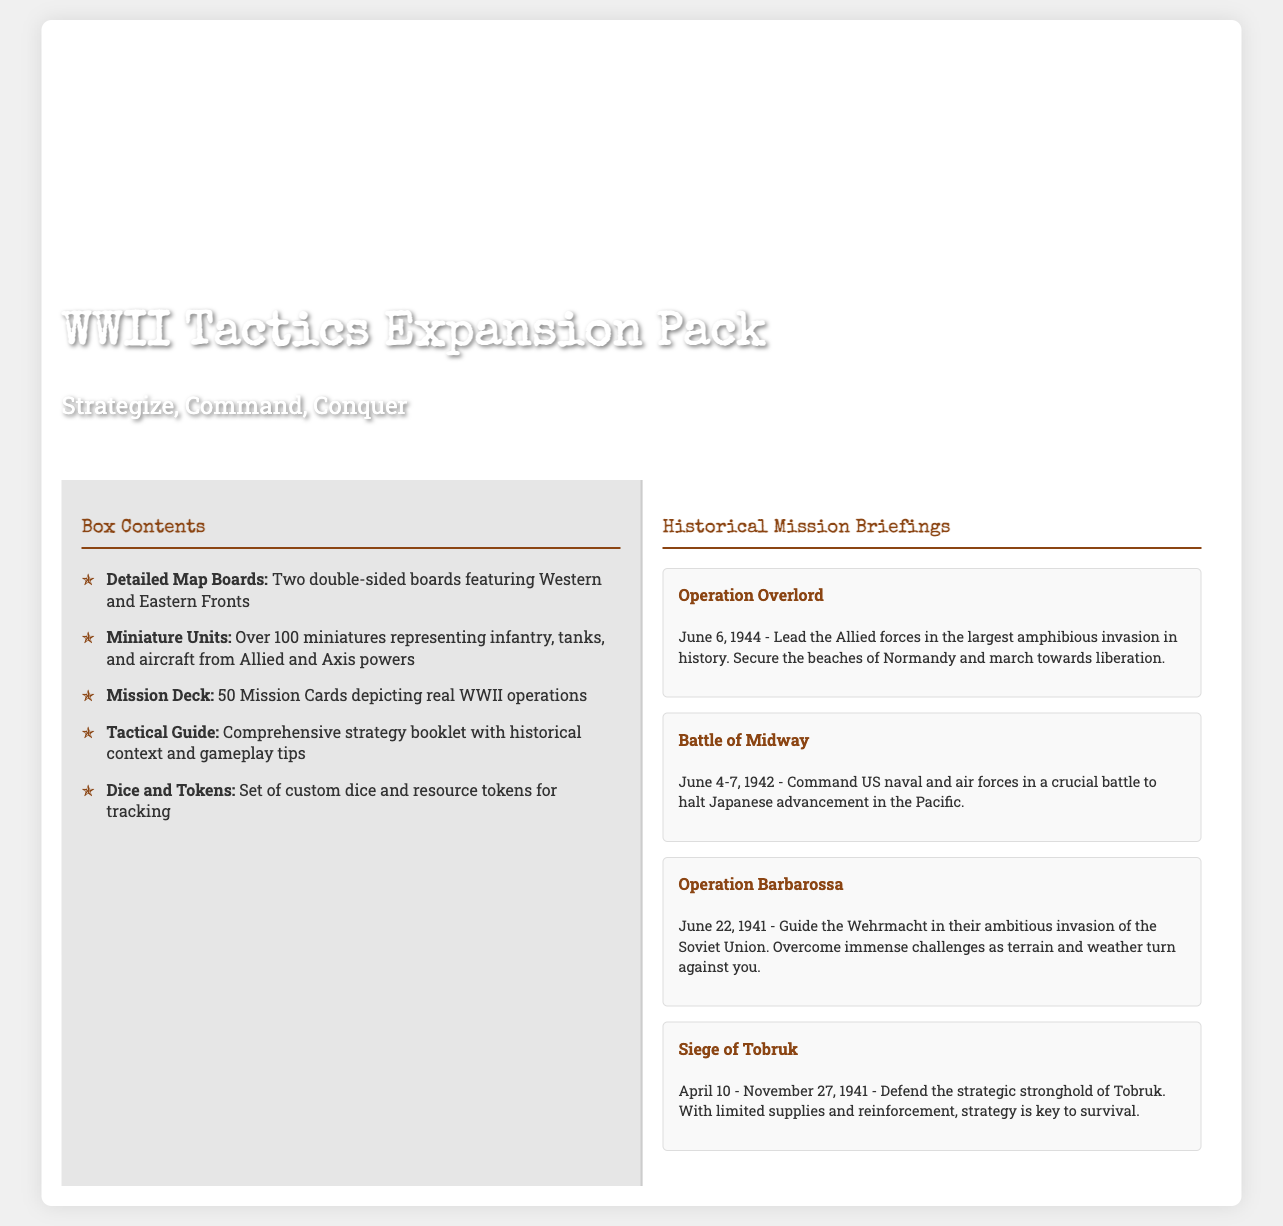What is the title of the expansion pack? The title "WWII Tactics Expansion Pack" is prominently displayed on the front cover of the product packaging.
Answer: WWII Tactics Expansion Pack How many mission cards are included? The back cover states there are "50 Mission Cards depicting real WWII operations."
Answer: 50 Mission Cards What is the date of Operation Overlord? The historical briefing inside the lid specifies the date "June 6, 1944" for Operation Overlord.
Answer: June 6, 1944 Which two fronts are featured on the map boards? The detailed component breakdown mentions "Western and Eastern Fronts" as the featured areas on the map boards.
Answer: Western and Eastern Fronts What is required to defend Tobruk? The mission briefing for the Siege of Tobruk indicates that "strategy is key to survival."
Answer: Strategy How many miniatures representing each side are included? The back cover specifies there are "over 100 miniatures representing infantry, tanks, and aircraft from Allied and Axis powers."
Answer: Over 100 miniatures What is the primary function of the Tactical Guide? The back cover describes the Tactical Guide as a "comprehensive strategy booklet with historical context and gameplay tips."
Answer: Comprehensive strategy booklet What is the timeframe covered by the Battle of Midway? The mission briefing states the timeframe as "June 4-7, 1942."
Answer: June 4-7, 1942 Which operation involves the Wehrmacht? The historical mission briefing for Operation Barbarossa lists the Wehrmacht as involved in their invasion of the Soviet Union.
Answer: Operation Barbarossa 